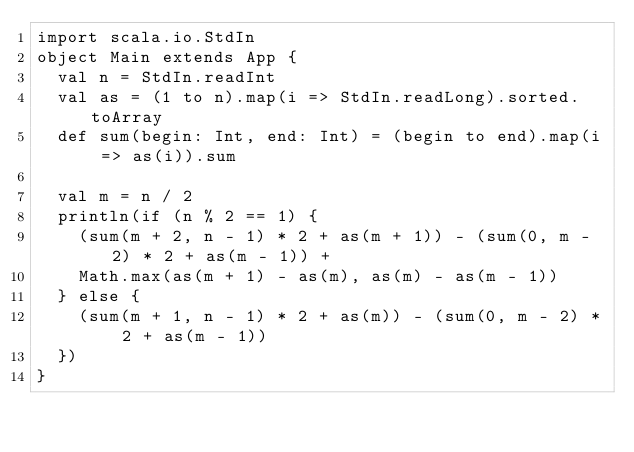<code> <loc_0><loc_0><loc_500><loc_500><_Scala_>import scala.io.StdIn
object Main extends App {
  val n = StdIn.readInt
  val as = (1 to n).map(i => StdIn.readLong).sorted.toArray
  def sum(begin: Int, end: Int) = (begin to end).map(i => as(i)).sum

  val m = n / 2
  println(if (n % 2 == 1) {
    (sum(m + 2, n - 1) * 2 + as(m + 1)) - (sum(0, m - 2) * 2 + as(m - 1)) +
    Math.max(as(m + 1) - as(m), as(m) - as(m - 1))
  } else {
    (sum(m + 1, n - 1) * 2 + as(m)) - (sum(0, m - 2) * 2 + as(m - 1))
  })
}</code> 